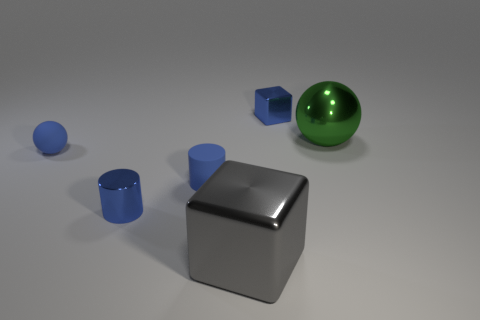Add 4 small blue matte balls. How many objects exist? 10 Subtract all blocks. How many objects are left? 4 Subtract all blue rubber cylinders. Subtract all large gray metallic cubes. How many objects are left? 4 Add 3 large gray metallic things. How many large gray metallic things are left? 4 Add 4 rubber objects. How many rubber objects exist? 6 Subtract 1 gray cubes. How many objects are left? 5 